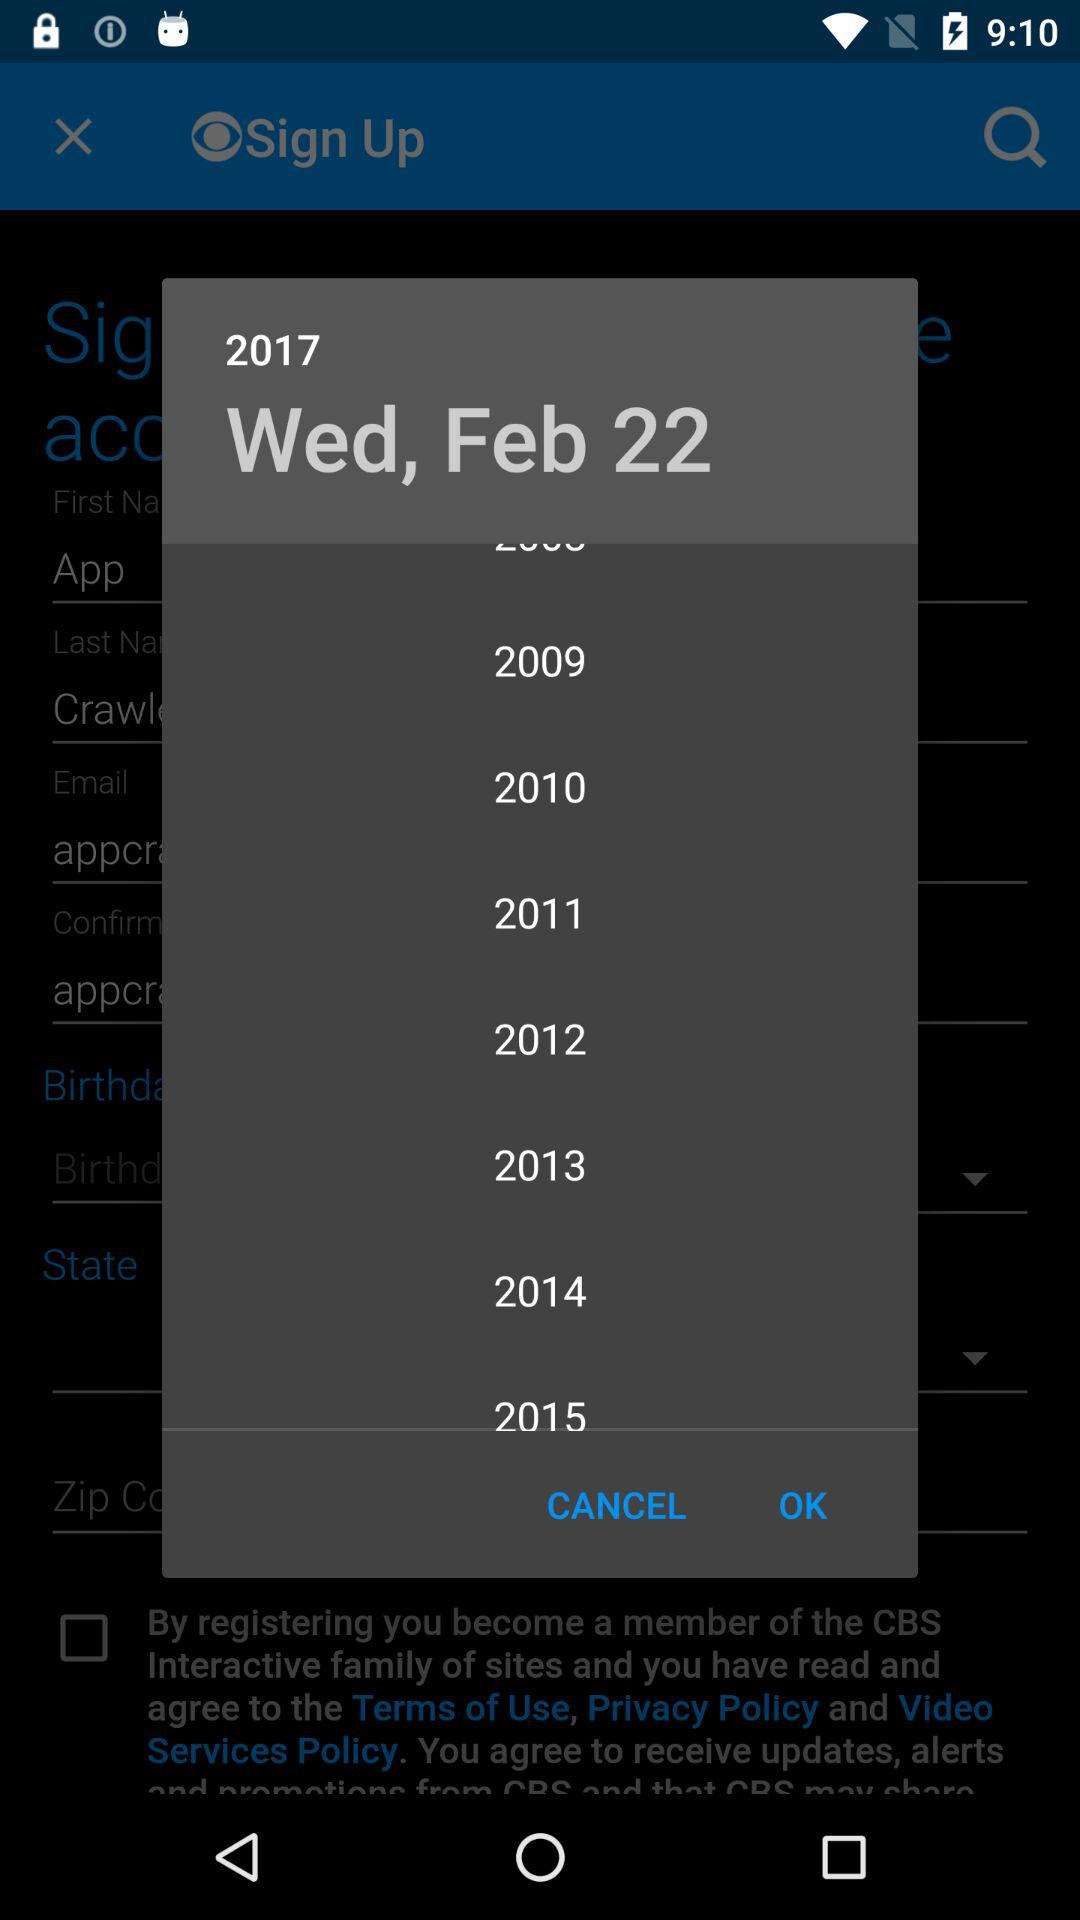What's the day on February 22nd, 2017? The day is Wednesday. 